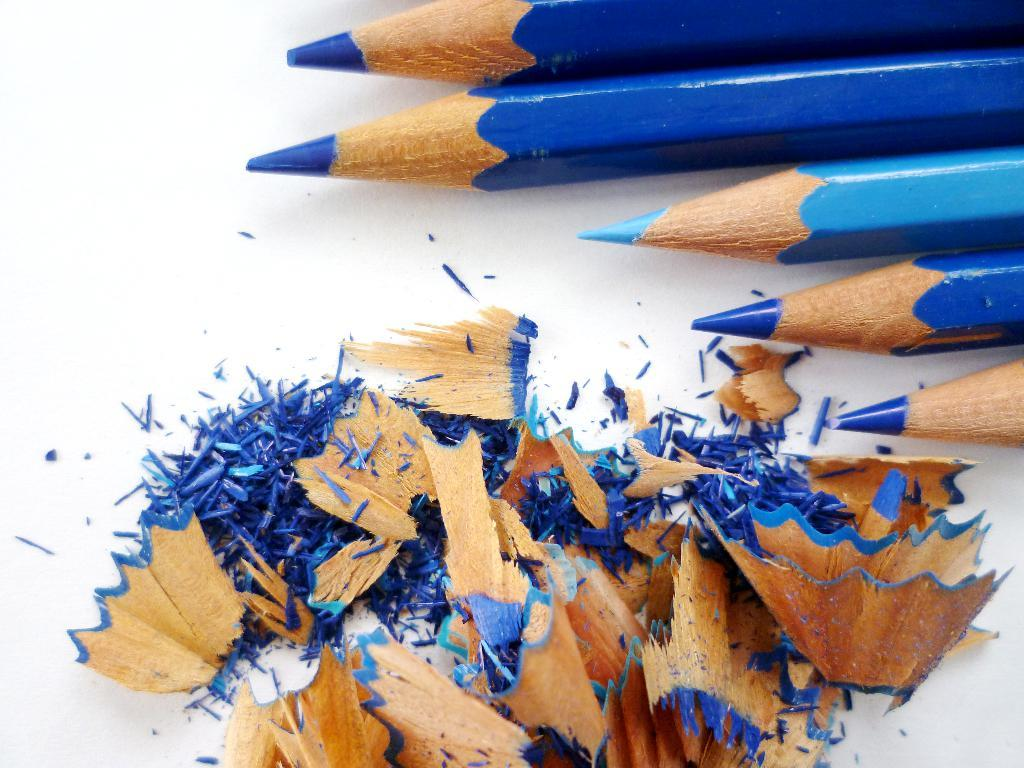How many pencils are visible in the image? There are 5 pencils in the image. What color are the pencils? The pencils are blue in color. What else can be seen in the image besides the pencils? There is dust visible in the image. On what surface are the pencils and dust located? The pencils and dust are on a white surface. Where is the jar of books and goat located in the image? There is no jar, books, or goat present in the image. 